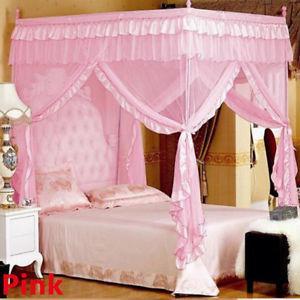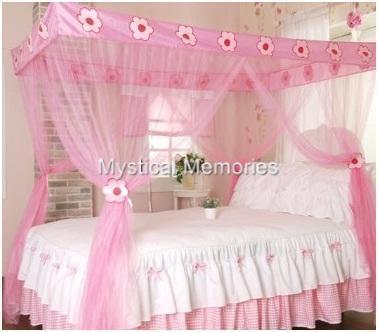The first image is the image on the left, the second image is the image on the right. Evaluate the accuracy of this statement regarding the images: "The image on the left contains a pink circular net over a bed.". Is it true? Answer yes or no. No. The first image is the image on the left, the second image is the image on the right. Given the left and right images, does the statement "One of the beds has four posts." hold true? Answer yes or no. Yes. 